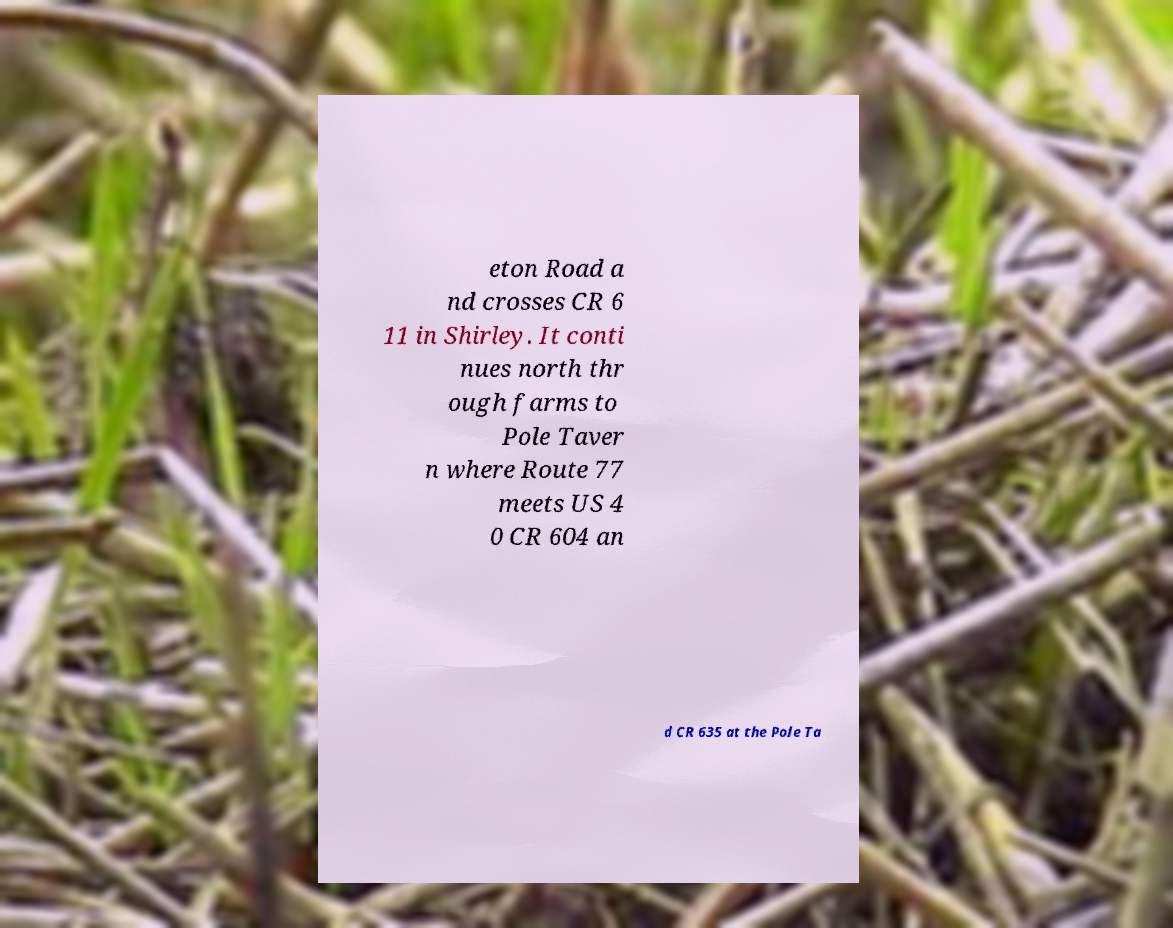Please identify and transcribe the text found in this image. eton Road a nd crosses CR 6 11 in Shirley. It conti nues north thr ough farms to Pole Taver n where Route 77 meets US 4 0 CR 604 an d CR 635 at the Pole Ta 